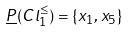Convert formula to latex. <formula><loc_0><loc_0><loc_500><loc_500>\underline { P } ( C l _ { 1 } ^ { \leq } ) = \{ x _ { 1 } , x _ { 5 } \}</formula> 